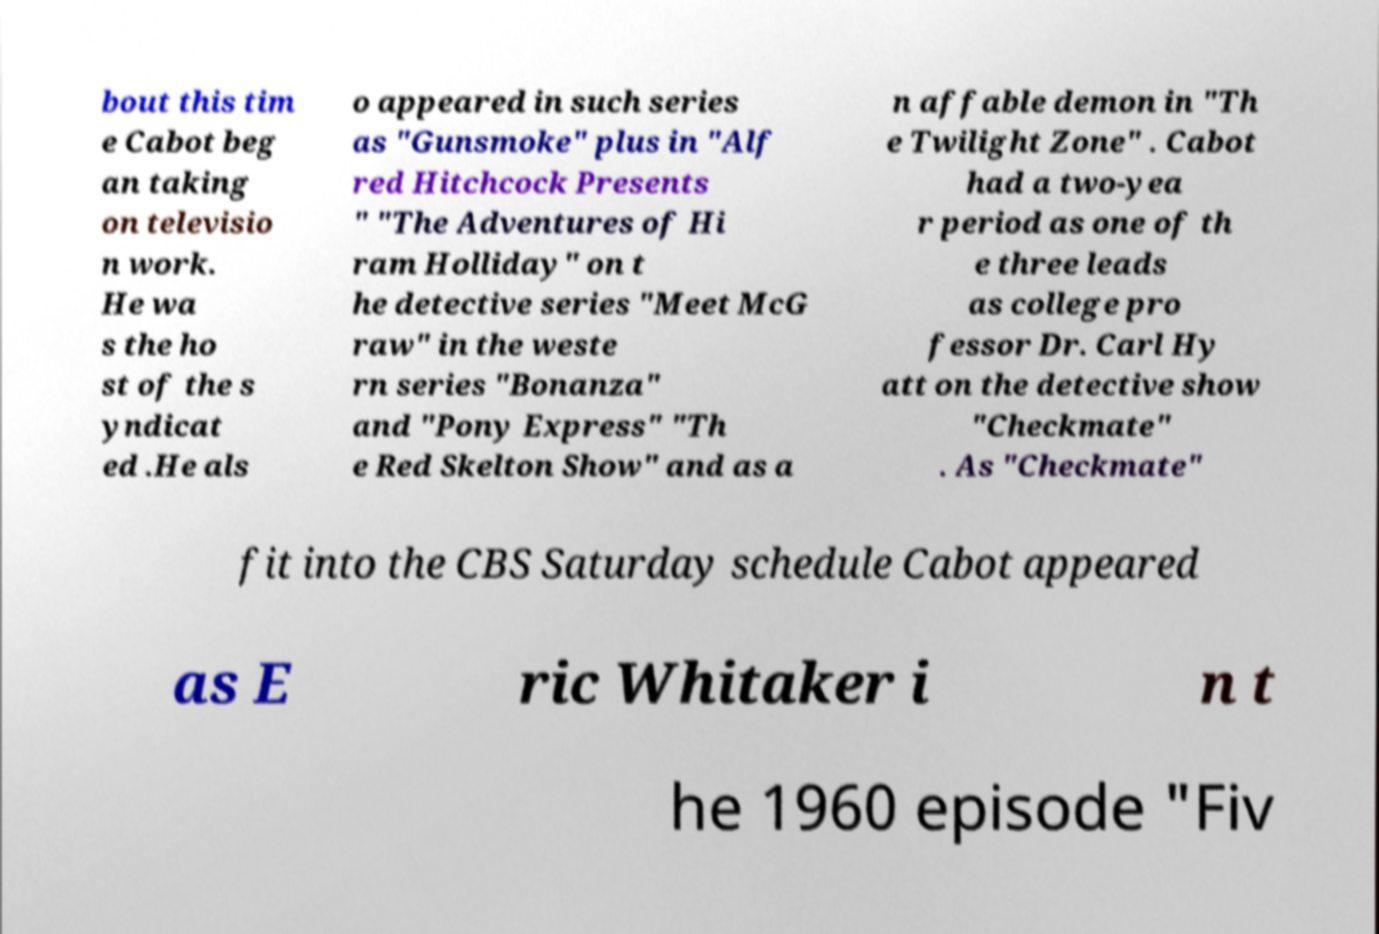What messages or text are displayed in this image? I need them in a readable, typed format. bout this tim e Cabot beg an taking on televisio n work. He wa s the ho st of the s yndicat ed .He als o appeared in such series as "Gunsmoke" plus in "Alf red Hitchcock Presents " "The Adventures of Hi ram Holliday" on t he detective series "Meet McG raw" in the weste rn series "Bonanza" and "Pony Express" "Th e Red Skelton Show" and as a n affable demon in "Th e Twilight Zone" . Cabot had a two-yea r period as one of th e three leads as college pro fessor Dr. Carl Hy att on the detective show "Checkmate" . As "Checkmate" fit into the CBS Saturday schedule Cabot appeared as E ric Whitaker i n t he 1960 episode "Fiv 